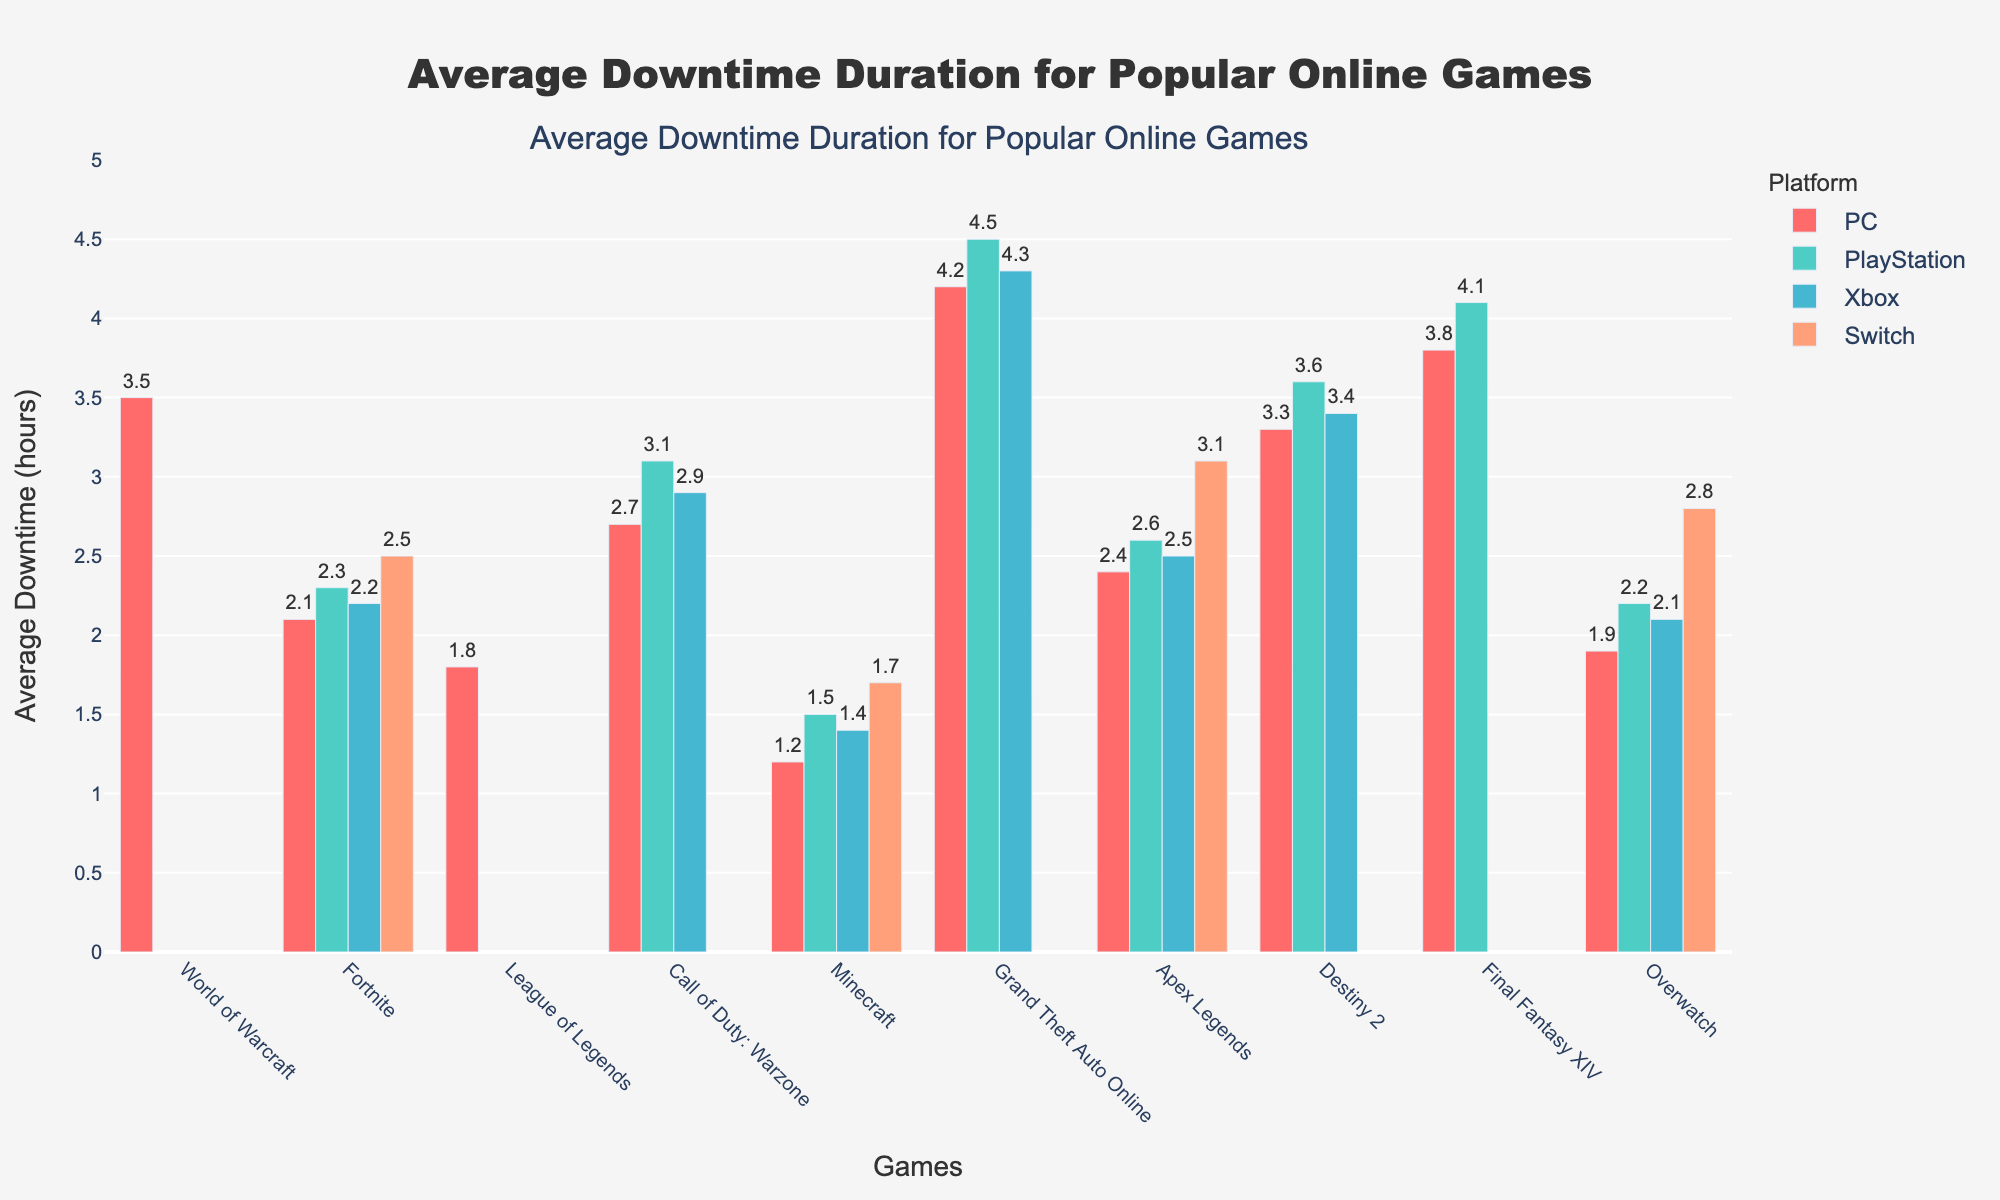What's the average downtime duration for "Fortnite" across all platforms? To find the average downtime for "Fortnite," sum the downtimes for each platform and divide by the number of platforms. The downtimes are 2.1 (PC), 2.3 (PlayStation), 2.2 (Xbox), and 2.5 (Switch). The sum is 2.1 + 2.3 + 2.2 + 2.5 = 9.1. There are 4 platforms, so the average is 9.1 / 4 = 2.275 hours.
Answer: 2.275 Which game has the highest average downtime on the PlayStation platform? Compare the downtime values for all games on PlayStation. The highest value is 4.5 for "Grand Theft Auto Online."
Answer: Grand Theft Auto Online Does "Apex Legends" have a higher downtime duration on PC or Switch? Compare the bar heights for "Apex Legends" on PC and Switch. The downtime on PC is 2.4 hours, and on Switch, it is 3.1 hours. Switch has a higher downtime.
Answer: Switch How much longer is the average downtime for "Final Fantasy XIV" on PlayStation compared to "Overwatch" on the same platform? Subtract the average downtime of "Overwatch" on PlayStation from "Final Fantasy XIV" on PlayStation. For "Final Fantasy XIV," it’s 4.1 hours, and for "Overwatch," it’s 2.2 hours. The difference is 4.1 - 2.2 = 1.9 hours.
Answer: 1.9 hours Which game has the shortest average downtime on the PC platform? Compare the downtimes for all games on PC and identify the shortest. The shortest downtime is 1.2 hours for "Minecraft."
Answer: Minecraft How does the downtime of "Call of Duty: Warzone" on PC compare to its downtime on PlayStation and Xbox? Compare the downtimes for "Call of Duty: Warzone" on PC (2.7 hours), PlayStation (3.1 hours), and Xbox (2.9 hours). It is lower on PC (2.7) than both PlayStation (3.1) and Xbox (2.9).
Answer: Lower on PC What is the visual color used for representing data related to the Xbox platform? Identify the color of the bars corresponding to Xbox across the chart. The Xbox bars are colored blue.
Answer: Blue If you sum the average downtimes of "Destiny 2" and "Grand Theft Auto Online" on PC, what do you get? Add the downtimes for "Destiny 2" (3.3 hours) and "Grand Theft Auto Online" (4.2 hours) on PC. The sum is 3.3 + 4.2 = 7.5 hours.
Answer: 7.5 hours Is the average downtime for "Minecraft" on PC greater than that for "League of Legends"? Compare the average downtimes for "Minecraft" on PC (1.2 hours) and "League of Legends" (1.8 hours). "League of Legends" has a greater downtime.
Answer: No How many games have downtime durations listed for all four platforms? Check each game's downtime entries to count how many have values for all four platforms. "Fortnite," "Minecraft," and "Overwatch" have values for all four platforms.
Answer: 3 